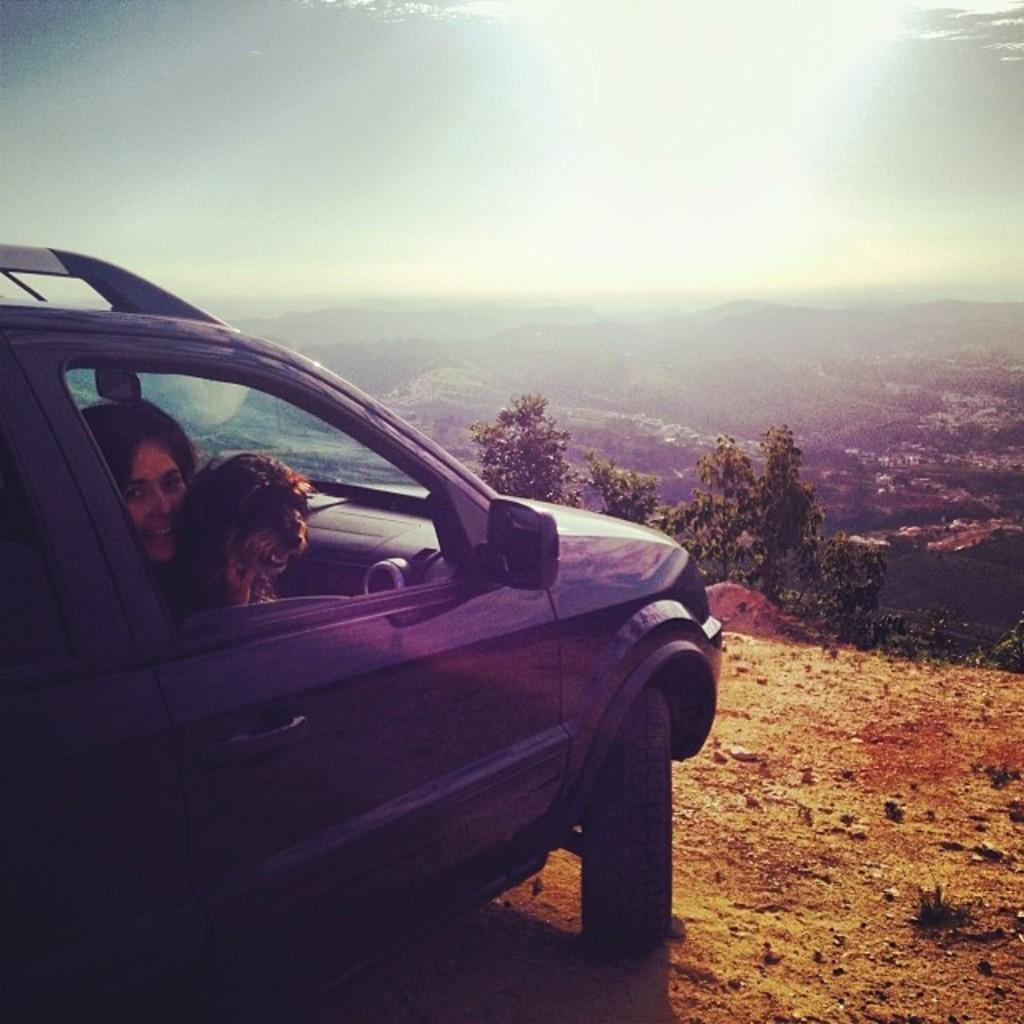What is the main subject of the image? The main subject of the image is a car on a hill. Who or what is inside the car? There is a woman and a dog in the car. How are the woman and dog positioned in the car? The woman and dog are sitting in the car seat. What can be seen at the top of the image? The sky is visible at the top of the image. What is present at the bottom of the image? There are hills and trees at the bottom of the image. Can you tell me what type of note the woman is holding in the image? There is no note visible in the image; the woman and dog are simply sitting in the car seat. 